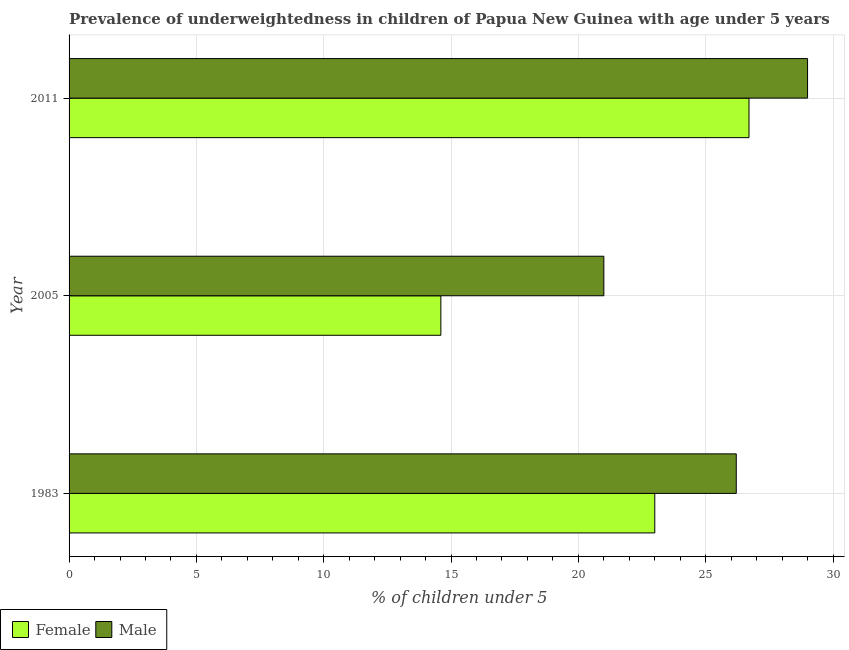How many different coloured bars are there?
Your answer should be compact. 2. Are the number of bars per tick equal to the number of legend labels?
Your answer should be very brief. Yes. In how many cases, is the number of bars for a given year not equal to the number of legend labels?
Your answer should be very brief. 0. What is the percentage of underweighted female children in 2011?
Offer a terse response. 26.7. Across all years, what is the minimum percentage of underweighted female children?
Offer a very short reply. 14.6. In which year was the percentage of underweighted male children maximum?
Offer a very short reply. 2011. In which year was the percentage of underweighted female children minimum?
Make the answer very short. 2005. What is the total percentage of underweighted female children in the graph?
Your response must be concise. 64.3. What is the difference between the percentage of underweighted female children in 1983 and that in 2005?
Your answer should be compact. 8.4. What is the average percentage of underweighted male children per year?
Provide a succinct answer. 25.4. In the year 1983, what is the difference between the percentage of underweighted male children and percentage of underweighted female children?
Keep it short and to the point. 3.2. What is the ratio of the percentage of underweighted male children in 1983 to that in 2011?
Provide a short and direct response. 0.9. What is the difference between the highest and the second highest percentage of underweighted male children?
Keep it short and to the point. 2.8. In how many years, is the percentage of underweighted male children greater than the average percentage of underweighted male children taken over all years?
Provide a short and direct response. 2. Is the sum of the percentage of underweighted male children in 1983 and 2011 greater than the maximum percentage of underweighted female children across all years?
Your response must be concise. Yes. What does the 1st bar from the top in 2011 represents?
Your answer should be compact. Male. How many bars are there?
Provide a succinct answer. 6. Are all the bars in the graph horizontal?
Your response must be concise. Yes. How many years are there in the graph?
Ensure brevity in your answer.  3. What is the difference between two consecutive major ticks on the X-axis?
Offer a terse response. 5. Does the graph contain any zero values?
Ensure brevity in your answer.  No. Where does the legend appear in the graph?
Offer a terse response. Bottom left. What is the title of the graph?
Provide a succinct answer. Prevalence of underweightedness in children of Papua New Guinea with age under 5 years. What is the label or title of the X-axis?
Make the answer very short.  % of children under 5. What is the  % of children under 5 in Female in 1983?
Your answer should be very brief. 23. What is the  % of children under 5 of Male in 1983?
Offer a very short reply. 26.2. What is the  % of children under 5 in Female in 2005?
Offer a terse response. 14.6. What is the  % of children under 5 of Male in 2005?
Ensure brevity in your answer.  21. What is the  % of children under 5 of Female in 2011?
Offer a very short reply. 26.7. What is the  % of children under 5 of Male in 2011?
Give a very brief answer. 29. Across all years, what is the maximum  % of children under 5 of Female?
Offer a terse response. 26.7. Across all years, what is the maximum  % of children under 5 in Male?
Offer a terse response. 29. Across all years, what is the minimum  % of children under 5 in Female?
Your response must be concise. 14.6. What is the total  % of children under 5 in Female in the graph?
Offer a terse response. 64.3. What is the total  % of children under 5 in Male in the graph?
Ensure brevity in your answer.  76.2. What is the difference between the  % of children under 5 in Female in 1983 and that in 2011?
Your response must be concise. -3.7. What is the difference between the  % of children under 5 of Male in 1983 and that in 2011?
Provide a succinct answer. -2.8. What is the difference between the  % of children under 5 of Female in 2005 and that in 2011?
Give a very brief answer. -12.1. What is the difference between the  % of children under 5 of Female in 1983 and the  % of children under 5 of Male in 2005?
Provide a succinct answer. 2. What is the difference between the  % of children under 5 in Female in 2005 and the  % of children under 5 in Male in 2011?
Make the answer very short. -14.4. What is the average  % of children under 5 of Female per year?
Provide a short and direct response. 21.43. What is the average  % of children under 5 in Male per year?
Offer a very short reply. 25.4. In the year 2005, what is the difference between the  % of children under 5 in Female and  % of children under 5 in Male?
Your answer should be very brief. -6.4. In the year 2011, what is the difference between the  % of children under 5 of Female and  % of children under 5 of Male?
Offer a terse response. -2.3. What is the ratio of the  % of children under 5 of Female in 1983 to that in 2005?
Offer a very short reply. 1.58. What is the ratio of the  % of children under 5 of Male in 1983 to that in 2005?
Your answer should be very brief. 1.25. What is the ratio of the  % of children under 5 of Female in 1983 to that in 2011?
Your answer should be very brief. 0.86. What is the ratio of the  % of children under 5 in Male in 1983 to that in 2011?
Your answer should be very brief. 0.9. What is the ratio of the  % of children under 5 in Female in 2005 to that in 2011?
Provide a short and direct response. 0.55. What is the ratio of the  % of children under 5 in Male in 2005 to that in 2011?
Provide a short and direct response. 0.72. What is the difference between the highest and the lowest  % of children under 5 in Female?
Offer a very short reply. 12.1. 